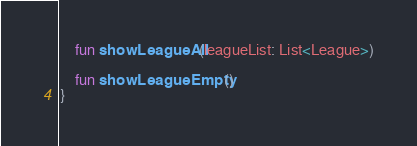Convert code to text. <code><loc_0><loc_0><loc_500><loc_500><_Kotlin_>    fun showLeagueAll(leagueList: List<League>)

    fun showLeagueEmpty()
}</code> 